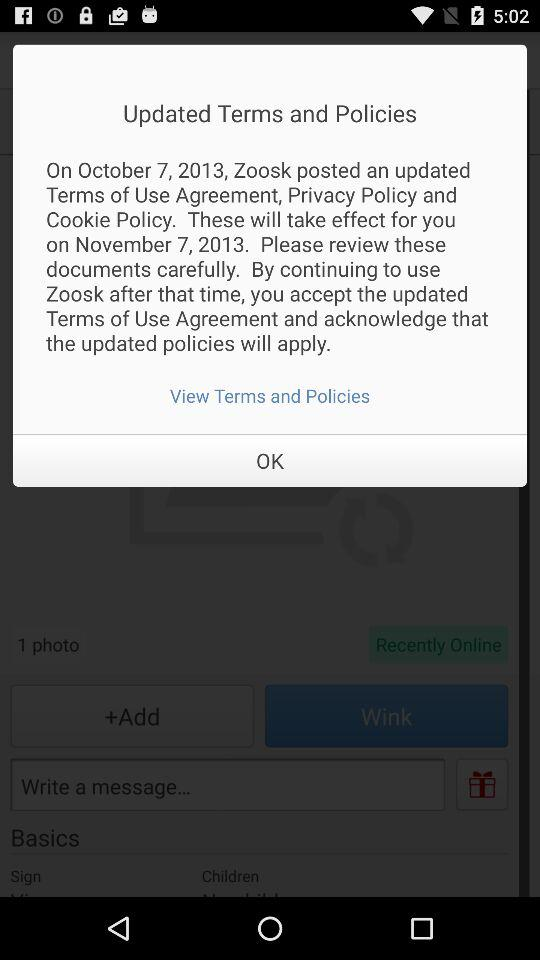On which date were the updated terms and policies posted? The updated terms and policies were posted on October 7, 2013. 